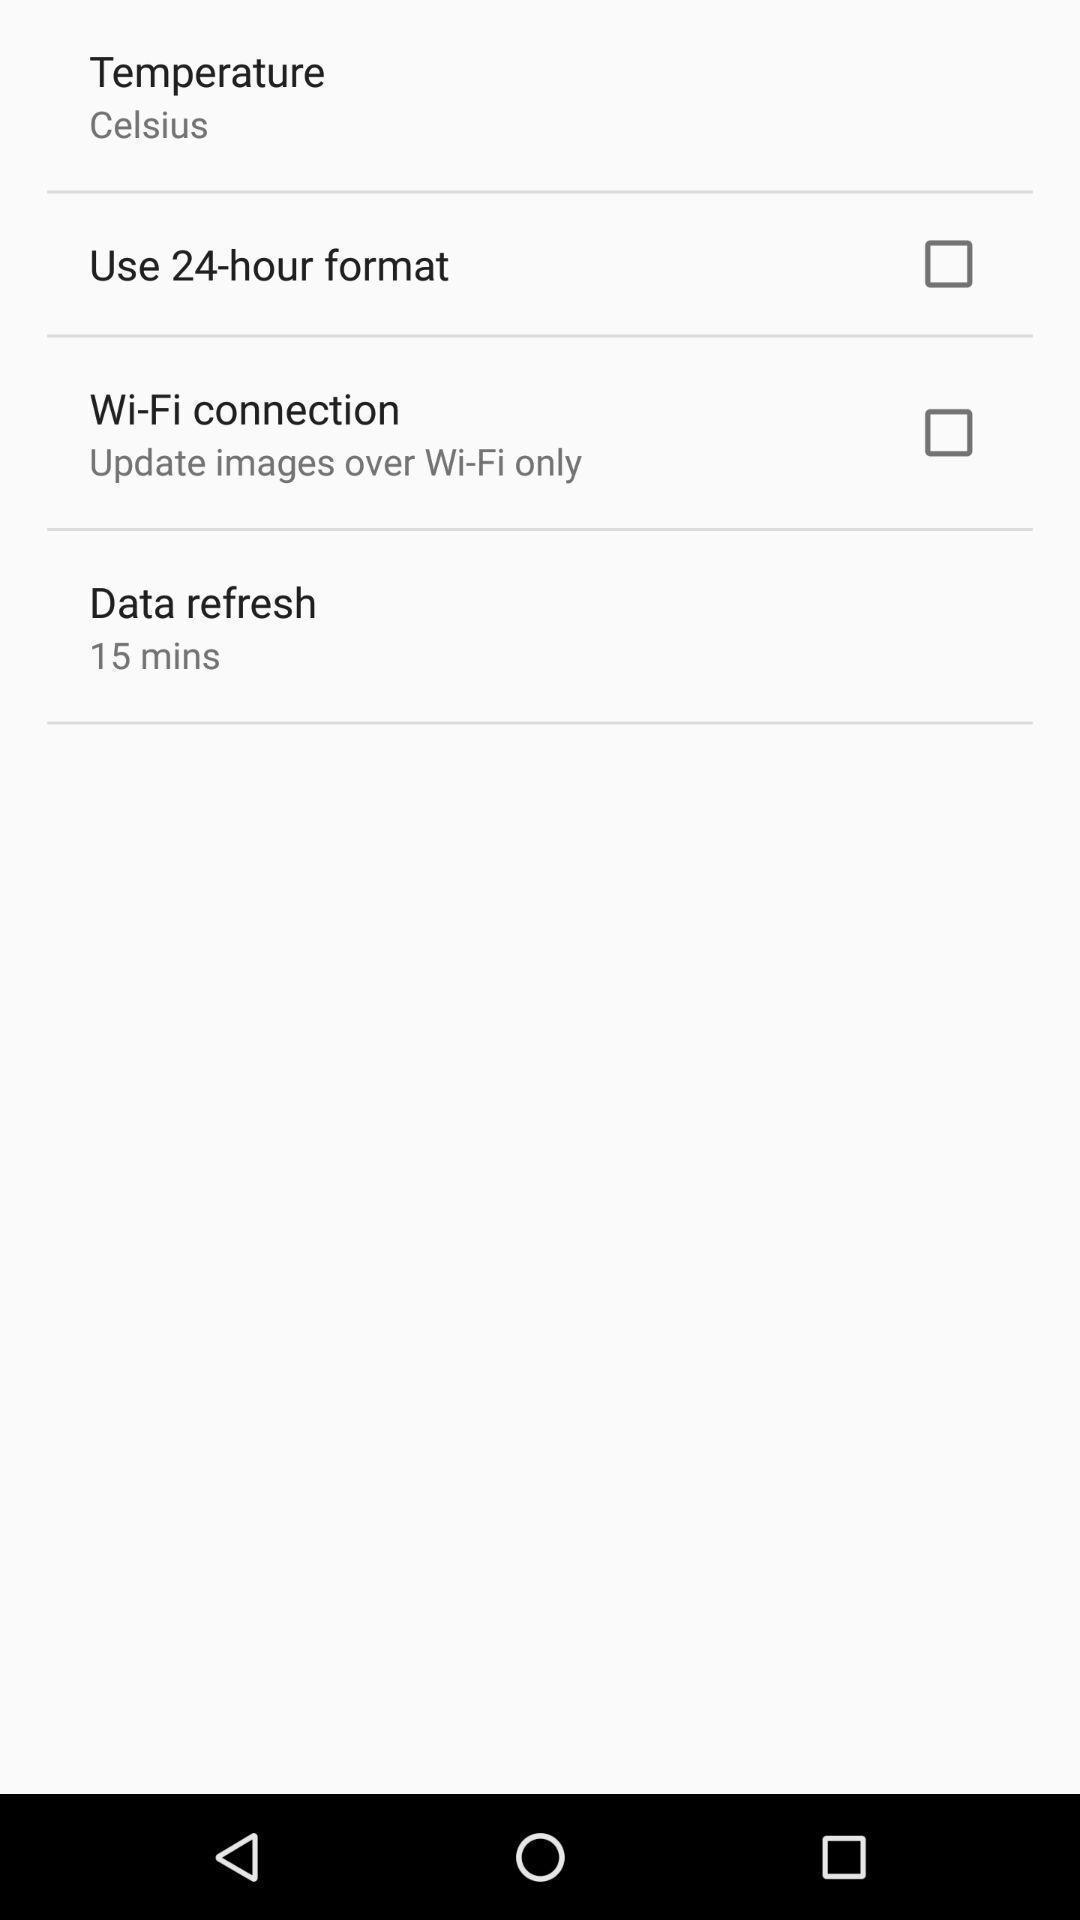What details can you identify in this image? Screen displaying the options for time formats. 